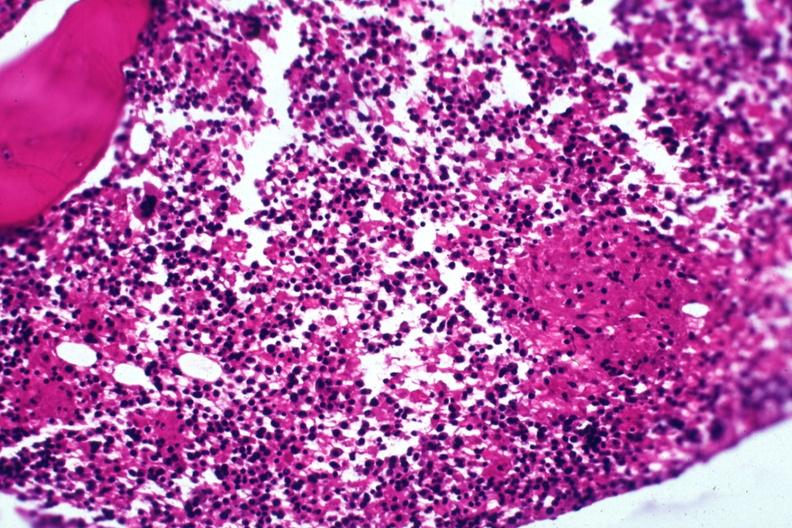does abruption show section granuloma shown but not too typical?
Answer the question using a single word or phrase. No 